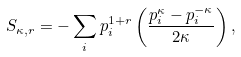<formula> <loc_0><loc_0><loc_500><loc_500>S _ { \kappa , r } = - \sum _ { i } p _ { i } ^ { 1 + r } \left ( \frac { p _ { i } ^ { \kappa } - p _ { i } ^ { - \kappa } } { 2 \kappa } \right ) ,</formula> 